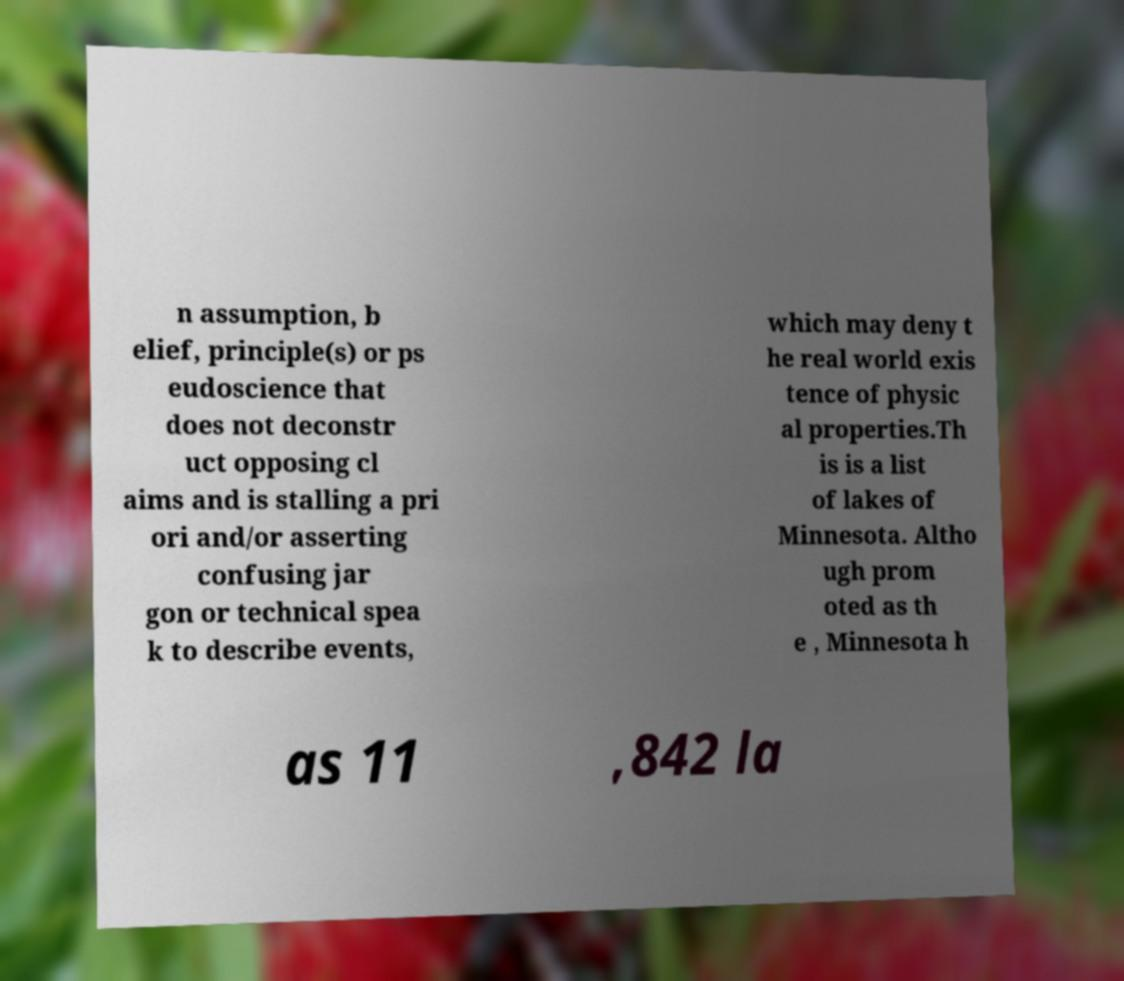I need the written content from this picture converted into text. Can you do that? n assumption, b elief, principle(s) or ps eudoscience that does not deconstr uct opposing cl aims and is stalling a pri ori and/or asserting confusing jar gon or technical spea k to describe events, which may deny t he real world exis tence of physic al properties.Th is is a list of lakes of Minnesota. Altho ugh prom oted as th e , Minnesota h as 11 ,842 la 